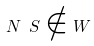<formula> <loc_0><loc_0><loc_500><loc_500>N \ S \notin W</formula> 